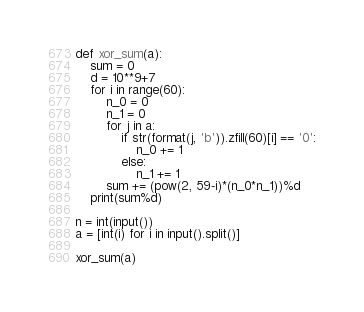<code> <loc_0><loc_0><loc_500><loc_500><_Python_>def xor_sum(a):
    sum = 0
    d = 10**9+7
    for i in range(60):
        n_0 = 0
        n_1 = 0
        for j in a:
            if str(format(j, 'b')).zfill(60)[i] == '0':
                n_0 += 1
            else:
                n_1 += 1
        sum += (pow(2, 59-i)*(n_0*n_1))%d
    print(sum%d)

n = int(input())
a = [int(i) for i in input().split()]

xor_sum(a)</code> 